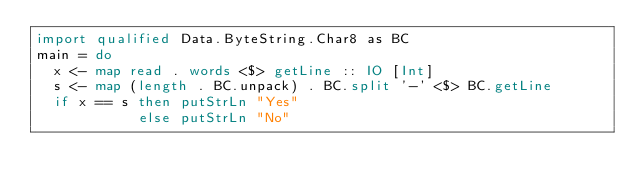<code> <loc_0><loc_0><loc_500><loc_500><_Haskell_>import qualified Data.ByteString.Char8 as BC
main = do
  x <- map read . words <$> getLine :: IO [Int]
  s <- map (length . BC.unpack) . BC.split '-' <$> BC.getLine
  if x == s then putStrLn "Yes"
            else putStrLn "No"
</code> 